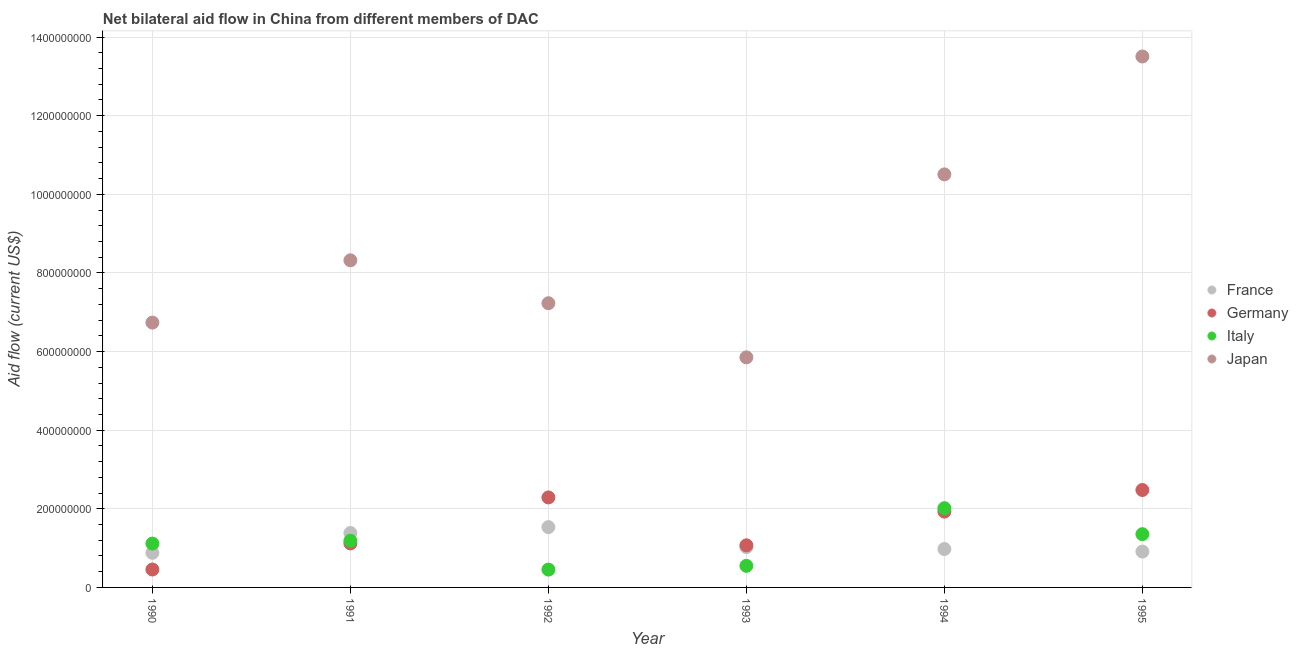What is the amount of aid given by france in 1991?
Provide a succinct answer. 1.38e+08. Across all years, what is the maximum amount of aid given by italy?
Keep it short and to the point. 2.02e+08. Across all years, what is the minimum amount of aid given by germany?
Ensure brevity in your answer.  4.56e+07. What is the total amount of aid given by italy in the graph?
Your response must be concise. 6.68e+08. What is the difference between the amount of aid given by japan in 1992 and that in 1994?
Offer a terse response. -3.28e+08. What is the difference between the amount of aid given by italy in 1994 and the amount of aid given by japan in 1995?
Provide a short and direct response. -1.15e+09. What is the average amount of aid given by japan per year?
Make the answer very short. 8.69e+08. In the year 1995, what is the difference between the amount of aid given by japan and amount of aid given by germany?
Offer a terse response. 1.10e+09. What is the ratio of the amount of aid given by italy in 1992 to that in 1993?
Ensure brevity in your answer.  0.83. Is the amount of aid given by france in 1990 less than that in 1994?
Your response must be concise. Yes. What is the difference between the highest and the second highest amount of aid given by france?
Give a very brief answer. 1.49e+07. What is the difference between the highest and the lowest amount of aid given by france?
Keep it short and to the point. 6.54e+07. In how many years, is the amount of aid given by japan greater than the average amount of aid given by japan taken over all years?
Make the answer very short. 2. Is the sum of the amount of aid given by japan in 1994 and 1995 greater than the maximum amount of aid given by germany across all years?
Give a very brief answer. Yes. Is it the case that in every year, the sum of the amount of aid given by france and amount of aid given by germany is greater than the amount of aid given by italy?
Give a very brief answer. Yes. Is the amount of aid given by france strictly greater than the amount of aid given by italy over the years?
Offer a terse response. No. Is the amount of aid given by italy strictly less than the amount of aid given by france over the years?
Offer a very short reply. No. How many years are there in the graph?
Make the answer very short. 6. Are the values on the major ticks of Y-axis written in scientific E-notation?
Ensure brevity in your answer.  No. Does the graph contain grids?
Offer a very short reply. Yes. How many legend labels are there?
Your response must be concise. 4. How are the legend labels stacked?
Your response must be concise. Vertical. What is the title of the graph?
Offer a terse response. Net bilateral aid flow in China from different members of DAC. What is the label or title of the X-axis?
Your answer should be compact. Year. What is the label or title of the Y-axis?
Offer a very short reply. Aid flow (current US$). What is the Aid flow (current US$) of France in 1990?
Provide a short and direct response. 8.80e+07. What is the Aid flow (current US$) of Germany in 1990?
Ensure brevity in your answer.  4.56e+07. What is the Aid flow (current US$) in Italy in 1990?
Your response must be concise. 1.12e+08. What is the Aid flow (current US$) of Japan in 1990?
Offer a very short reply. 6.74e+08. What is the Aid flow (current US$) of France in 1991?
Your answer should be compact. 1.38e+08. What is the Aid flow (current US$) in Germany in 1991?
Give a very brief answer. 1.12e+08. What is the Aid flow (current US$) of Italy in 1991?
Make the answer very short. 1.19e+08. What is the Aid flow (current US$) in Japan in 1991?
Offer a very short reply. 8.32e+08. What is the Aid flow (current US$) in France in 1992?
Provide a succinct answer. 1.53e+08. What is the Aid flow (current US$) in Germany in 1992?
Ensure brevity in your answer.  2.29e+08. What is the Aid flow (current US$) of Italy in 1992?
Offer a very short reply. 4.53e+07. What is the Aid flow (current US$) in Japan in 1992?
Give a very brief answer. 7.23e+08. What is the Aid flow (current US$) of France in 1993?
Keep it short and to the point. 1.03e+08. What is the Aid flow (current US$) of Germany in 1993?
Offer a terse response. 1.07e+08. What is the Aid flow (current US$) in Italy in 1993?
Your answer should be very brief. 5.49e+07. What is the Aid flow (current US$) of Japan in 1993?
Your answer should be compact. 5.85e+08. What is the Aid flow (current US$) in France in 1994?
Your answer should be compact. 9.77e+07. What is the Aid flow (current US$) of Germany in 1994?
Your answer should be compact. 1.93e+08. What is the Aid flow (current US$) of Italy in 1994?
Your answer should be very brief. 2.02e+08. What is the Aid flow (current US$) in Japan in 1994?
Keep it short and to the point. 1.05e+09. What is the Aid flow (current US$) of France in 1995?
Make the answer very short. 9.12e+07. What is the Aid flow (current US$) of Germany in 1995?
Ensure brevity in your answer.  2.48e+08. What is the Aid flow (current US$) in Italy in 1995?
Your answer should be compact. 1.35e+08. What is the Aid flow (current US$) of Japan in 1995?
Offer a terse response. 1.35e+09. Across all years, what is the maximum Aid flow (current US$) of France?
Offer a terse response. 1.53e+08. Across all years, what is the maximum Aid flow (current US$) in Germany?
Provide a succinct answer. 2.48e+08. Across all years, what is the maximum Aid flow (current US$) of Italy?
Provide a succinct answer. 2.02e+08. Across all years, what is the maximum Aid flow (current US$) of Japan?
Offer a terse response. 1.35e+09. Across all years, what is the minimum Aid flow (current US$) in France?
Make the answer very short. 8.80e+07. Across all years, what is the minimum Aid flow (current US$) in Germany?
Offer a very short reply. 4.56e+07. Across all years, what is the minimum Aid flow (current US$) in Italy?
Your answer should be compact. 4.53e+07. Across all years, what is the minimum Aid flow (current US$) of Japan?
Provide a short and direct response. 5.85e+08. What is the total Aid flow (current US$) of France in the graph?
Your response must be concise. 6.71e+08. What is the total Aid flow (current US$) in Germany in the graph?
Make the answer very short. 9.34e+08. What is the total Aid flow (current US$) of Italy in the graph?
Your response must be concise. 6.68e+08. What is the total Aid flow (current US$) of Japan in the graph?
Provide a succinct answer. 5.22e+09. What is the difference between the Aid flow (current US$) of France in 1990 and that in 1991?
Your response must be concise. -5.04e+07. What is the difference between the Aid flow (current US$) of Germany in 1990 and that in 1991?
Offer a very short reply. -6.63e+07. What is the difference between the Aid flow (current US$) of Italy in 1990 and that in 1991?
Make the answer very short. -7.29e+06. What is the difference between the Aid flow (current US$) in Japan in 1990 and that in 1991?
Your answer should be very brief. -1.58e+08. What is the difference between the Aid flow (current US$) in France in 1990 and that in 1992?
Make the answer very short. -6.54e+07. What is the difference between the Aid flow (current US$) of Germany in 1990 and that in 1992?
Your response must be concise. -1.83e+08. What is the difference between the Aid flow (current US$) of Italy in 1990 and that in 1992?
Provide a succinct answer. 6.62e+07. What is the difference between the Aid flow (current US$) of Japan in 1990 and that in 1992?
Provide a succinct answer. -4.93e+07. What is the difference between the Aid flow (current US$) in France in 1990 and that in 1993?
Your answer should be compact. -1.45e+07. What is the difference between the Aid flow (current US$) in Germany in 1990 and that in 1993?
Offer a terse response. -6.15e+07. What is the difference between the Aid flow (current US$) of Italy in 1990 and that in 1993?
Provide a succinct answer. 5.66e+07. What is the difference between the Aid flow (current US$) of Japan in 1990 and that in 1993?
Offer a very short reply. 8.84e+07. What is the difference between the Aid flow (current US$) of France in 1990 and that in 1994?
Offer a terse response. -9.65e+06. What is the difference between the Aid flow (current US$) of Germany in 1990 and that in 1994?
Make the answer very short. -1.47e+08. What is the difference between the Aid flow (current US$) in Italy in 1990 and that in 1994?
Your response must be concise. -9.00e+07. What is the difference between the Aid flow (current US$) in Japan in 1990 and that in 1994?
Provide a succinct answer. -3.77e+08. What is the difference between the Aid flow (current US$) in France in 1990 and that in 1995?
Offer a very short reply. -3.16e+06. What is the difference between the Aid flow (current US$) of Germany in 1990 and that in 1995?
Keep it short and to the point. -2.02e+08. What is the difference between the Aid flow (current US$) of Italy in 1990 and that in 1995?
Your response must be concise. -2.39e+07. What is the difference between the Aid flow (current US$) of Japan in 1990 and that in 1995?
Offer a terse response. -6.77e+08. What is the difference between the Aid flow (current US$) of France in 1991 and that in 1992?
Provide a short and direct response. -1.49e+07. What is the difference between the Aid flow (current US$) of Germany in 1991 and that in 1992?
Offer a very short reply. -1.17e+08. What is the difference between the Aid flow (current US$) of Italy in 1991 and that in 1992?
Make the answer very short. 7.35e+07. What is the difference between the Aid flow (current US$) in Japan in 1991 and that in 1992?
Keep it short and to the point. 1.09e+08. What is the difference between the Aid flow (current US$) of France in 1991 and that in 1993?
Give a very brief answer. 3.59e+07. What is the difference between the Aid flow (current US$) of Germany in 1991 and that in 1993?
Make the answer very short. 4.80e+06. What is the difference between the Aid flow (current US$) in Italy in 1991 and that in 1993?
Your answer should be very brief. 6.39e+07. What is the difference between the Aid flow (current US$) in Japan in 1991 and that in 1993?
Ensure brevity in your answer.  2.47e+08. What is the difference between the Aid flow (current US$) in France in 1991 and that in 1994?
Provide a succinct answer. 4.08e+07. What is the difference between the Aid flow (current US$) of Germany in 1991 and that in 1994?
Provide a short and direct response. -8.09e+07. What is the difference between the Aid flow (current US$) of Italy in 1991 and that in 1994?
Provide a short and direct response. -8.28e+07. What is the difference between the Aid flow (current US$) of Japan in 1991 and that in 1994?
Offer a very short reply. -2.19e+08. What is the difference between the Aid flow (current US$) of France in 1991 and that in 1995?
Give a very brief answer. 4.73e+07. What is the difference between the Aid flow (current US$) in Germany in 1991 and that in 1995?
Offer a very short reply. -1.36e+08. What is the difference between the Aid flow (current US$) in Italy in 1991 and that in 1995?
Offer a very short reply. -1.66e+07. What is the difference between the Aid flow (current US$) of Japan in 1991 and that in 1995?
Make the answer very short. -5.18e+08. What is the difference between the Aid flow (current US$) of France in 1992 and that in 1993?
Provide a succinct answer. 5.08e+07. What is the difference between the Aid flow (current US$) of Germany in 1992 and that in 1993?
Ensure brevity in your answer.  1.22e+08. What is the difference between the Aid flow (current US$) in Italy in 1992 and that in 1993?
Offer a very short reply. -9.57e+06. What is the difference between the Aid flow (current US$) in Japan in 1992 and that in 1993?
Provide a succinct answer. 1.38e+08. What is the difference between the Aid flow (current US$) of France in 1992 and that in 1994?
Provide a short and direct response. 5.57e+07. What is the difference between the Aid flow (current US$) in Germany in 1992 and that in 1994?
Your answer should be very brief. 3.61e+07. What is the difference between the Aid flow (current US$) of Italy in 1992 and that in 1994?
Keep it short and to the point. -1.56e+08. What is the difference between the Aid flow (current US$) in Japan in 1992 and that in 1994?
Keep it short and to the point. -3.28e+08. What is the difference between the Aid flow (current US$) of France in 1992 and that in 1995?
Make the answer very short. 6.22e+07. What is the difference between the Aid flow (current US$) of Germany in 1992 and that in 1995?
Keep it short and to the point. -1.89e+07. What is the difference between the Aid flow (current US$) in Italy in 1992 and that in 1995?
Give a very brief answer. -9.02e+07. What is the difference between the Aid flow (current US$) in Japan in 1992 and that in 1995?
Ensure brevity in your answer.  -6.28e+08. What is the difference between the Aid flow (current US$) of France in 1993 and that in 1994?
Your response must be concise. 4.89e+06. What is the difference between the Aid flow (current US$) of Germany in 1993 and that in 1994?
Give a very brief answer. -8.57e+07. What is the difference between the Aid flow (current US$) in Italy in 1993 and that in 1994?
Offer a terse response. -1.47e+08. What is the difference between the Aid flow (current US$) in Japan in 1993 and that in 1994?
Your answer should be very brief. -4.65e+08. What is the difference between the Aid flow (current US$) in France in 1993 and that in 1995?
Provide a succinct answer. 1.14e+07. What is the difference between the Aid flow (current US$) of Germany in 1993 and that in 1995?
Offer a terse response. -1.41e+08. What is the difference between the Aid flow (current US$) in Italy in 1993 and that in 1995?
Offer a terse response. -8.06e+07. What is the difference between the Aid flow (current US$) in Japan in 1993 and that in 1995?
Offer a terse response. -7.65e+08. What is the difference between the Aid flow (current US$) in France in 1994 and that in 1995?
Your answer should be compact. 6.49e+06. What is the difference between the Aid flow (current US$) of Germany in 1994 and that in 1995?
Your response must be concise. -5.50e+07. What is the difference between the Aid flow (current US$) in Italy in 1994 and that in 1995?
Your answer should be very brief. 6.61e+07. What is the difference between the Aid flow (current US$) in Japan in 1994 and that in 1995?
Keep it short and to the point. -3.00e+08. What is the difference between the Aid flow (current US$) in France in 1990 and the Aid flow (current US$) in Germany in 1991?
Keep it short and to the point. -2.39e+07. What is the difference between the Aid flow (current US$) in France in 1990 and the Aid flow (current US$) in Italy in 1991?
Provide a succinct answer. -3.08e+07. What is the difference between the Aid flow (current US$) of France in 1990 and the Aid flow (current US$) of Japan in 1991?
Ensure brevity in your answer.  -7.44e+08. What is the difference between the Aid flow (current US$) in Germany in 1990 and the Aid flow (current US$) in Italy in 1991?
Your answer should be very brief. -7.33e+07. What is the difference between the Aid flow (current US$) in Germany in 1990 and the Aid flow (current US$) in Japan in 1991?
Ensure brevity in your answer.  -7.87e+08. What is the difference between the Aid flow (current US$) of Italy in 1990 and the Aid flow (current US$) of Japan in 1991?
Offer a very short reply. -7.21e+08. What is the difference between the Aid flow (current US$) in France in 1990 and the Aid flow (current US$) in Germany in 1992?
Your response must be concise. -1.41e+08. What is the difference between the Aid flow (current US$) of France in 1990 and the Aid flow (current US$) of Italy in 1992?
Ensure brevity in your answer.  4.27e+07. What is the difference between the Aid flow (current US$) of France in 1990 and the Aid flow (current US$) of Japan in 1992?
Your response must be concise. -6.35e+08. What is the difference between the Aid flow (current US$) of Germany in 1990 and the Aid flow (current US$) of Italy in 1992?
Make the answer very short. 2.40e+05. What is the difference between the Aid flow (current US$) in Germany in 1990 and the Aid flow (current US$) in Japan in 1992?
Offer a terse response. -6.77e+08. What is the difference between the Aid flow (current US$) of Italy in 1990 and the Aid flow (current US$) of Japan in 1992?
Your answer should be compact. -6.11e+08. What is the difference between the Aid flow (current US$) of France in 1990 and the Aid flow (current US$) of Germany in 1993?
Ensure brevity in your answer.  -1.91e+07. What is the difference between the Aid flow (current US$) in France in 1990 and the Aid flow (current US$) in Italy in 1993?
Your answer should be compact. 3.31e+07. What is the difference between the Aid flow (current US$) of France in 1990 and the Aid flow (current US$) of Japan in 1993?
Keep it short and to the point. -4.97e+08. What is the difference between the Aid flow (current US$) of Germany in 1990 and the Aid flow (current US$) of Italy in 1993?
Provide a succinct answer. -9.33e+06. What is the difference between the Aid flow (current US$) in Germany in 1990 and the Aid flow (current US$) in Japan in 1993?
Give a very brief answer. -5.40e+08. What is the difference between the Aid flow (current US$) of Italy in 1990 and the Aid flow (current US$) of Japan in 1993?
Your answer should be very brief. -4.74e+08. What is the difference between the Aid flow (current US$) in France in 1990 and the Aid flow (current US$) in Germany in 1994?
Keep it short and to the point. -1.05e+08. What is the difference between the Aid flow (current US$) in France in 1990 and the Aid flow (current US$) in Italy in 1994?
Provide a succinct answer. -1.14e+08. What is the difference between the Aid flow (current US$) in France in 1990 and the Aid flow (current US$) in Japan in 1994?
Give a very brief answer. -9.63e+08. What is the difference between the Aid flow (current US$) of Germany in 1990 and the Aid flow (current US$) of Italy in 1994?
Your answer should be very brief. -1.56e+08. What is the difference between the Aid flow (current US$) of Germany in 1990 and the Aid flow (current US$) of Japan in 1994?
Give a very brief answer. -1.01e+09. What is the difference between the Aid flow (current US$) of Italy in 1990 and the Aid flow (current US$) of Japan in 1994?
Make the answer very short. -9.39e+08. What is the difference between the Aid flow (current US$) in France in 1990 and the Aid flow (current US$) in Germany in 1995?
Keep it short and to the point. -1.60e+08. What is the difference between the Aid flow (current US$) in France in 1990 and the Aid flow (current US$) in Italy in 1995?
Provide a short and direct response. -4.75e+07. What is the difference between the Aid flow (current US$) in France in 1990 and the Aid flow (current US$) in Japan in 1995?
Provide a succinct answer. -1.26e+09. What is the difference between the Aid flow (current US$) in Germany in 1990 and the Aid flow (current US$) in Italy in 1995?
Offer a very short reply. -8.99e+07. What is the difference between the Aid flow (current US$) in Germany in 1990 and the Aid flow (current US$) in Japan in 1995?
Provide a succinct answer. -1.31e+09. What is the difference between the Aid flow (current US$) in Italy in 1990 and the Aid flow (current US$) in Japan in 1995?
Your response must be concise. -1.24e+09. What is the difference between the Aid flow (current US$) of France in 1991 and the Aid flow (current US$) of Germany in 1992?
Offer a terse response. -9.05e+07. What is the difference between the Aid flow (current US$) of France in 1991 and the Aid flow (current US$) of Italy in 1992?
Give a very brief answer. 9.31e+07. What is the difference between the Aid flow (current US$) in France in 1991 and the Aid flow (current US$) in Japan in 1992?
Make the answer very short. -5.85e+08. What is the difference between the Aid flow (current US$) of Germany in 1991 and the Aid flow (current US$) of Italy in 1992?
Your response must be concise. 6.66e+07. What is the difference between the Aid flow (current US$) in Germany in 1991 and the Aid flow (current US$) in Japan in 1992?
Offer a terse response. -6.11e+08. What is the difference between the Aid flow (current US$) in Italy in 1991 and the Aid flow (current US$) in Japan in 1992?
Offer a terse response. -6.04e+08. What is the difference between the Aid flow (current US$) in France in 1991 and the Aid flow (current US$) in Germany in 1993?
Keep it short and to the point. 3.14e+07. What is the difference between the Aid flow (current US$) in France in 1991 and the Aid flow (current US$) in Italy in 1993?
Your answer should be very brief. 8.36e+07. What is the difference between the Aid flow (current US$) in France in 1991 and the Aid flow (current US$) in Japan in 1993?
Your answer should be compact. -4.47e+08. What is the difference between the Aid flow (current US$) of Germany in 1991 and the Aid flow (current US$) of Italy in 1993?
Provide a short and direct response. 5.70e+07. What is the difference between the Aid flow (current US$) of Germany in 1991 and the Aid flow (current US$) of Japan in 1993?
Your answer should be very brief. -4.73e+08. What is the difference between the Aid flow (current US$) of Italy in 1991 and the Aid flow (current US$) of Japan in 1993?
Make the answer very short. -4.66e+08. What is the difference between the Aid flow (current US$) of France in 1991 and the Aid flow (current US$) of Germany in 1994?
Offer a terse response. -5.44e+07. What is the difference between the Aid flow (current US$) of France in 1991 and the Aid flow (current US$) of Italy in 1994?
Make the answer very short. -6.31e+07. What is the difference between the Aid flow (current US$) of France in 1991 and the Aid flow (current US$) of Japan in 1994?
Your answer should be very brief. -9.12e+08. What is the difference between the Aid flow (current US$) of Germany in 1991 and the Aid flow (current US$) of Italy in 1994?
Offer a terse response. -8.97e+07. What is the difference between the Aid flow (current US$) of Germany in 1991 and the Aid flow (current US$) of Japan in 1994?
Offer a very short reply. -9.39e+08. What is the difference between the Aid flow (current US$) of Italy in 1991 and the Aid flow (current US$) of Japan in 1994?
Keep it short and to the point. -9.32e+08. What is the difference between the Aid flow (current US$) in France in 1991 and the Aid flow (current US$) in Germany in 1995?
Offer a very short reply. -1.09e+08. What is the difference between the Aid flow (current US$) of France in 1991 and the Aid flow (current US$) of Italy in 1995?
Your response must be concise. 2.98e+06. What is the difference between the Aid flow (current US$) in France in 1991 and the Aid flow (current US$) in Japan in 1995?
Your response must be concise. -1.21e+09. What is the difference between the Aid flow (current US$) of Germany in 1991 and the Aid flow (current US$) of Italy in 1995?
Make the answer very short. -2.36e+07. What is the difference between the Aid flow (current US$) of Germany in 1991 and the Aid flow (current US$) of Japan in 1995?
Your answer should be very brief. -1.24e+09. What is the difference between the Aid flow (current US$) of Italy in 1991 and the Aid flow (current US$) of Japan in 1995?
Give a very brief answer. -1.23e+09. What is the difference between the Aid flow (current US$) of France in 1992 and the Aid flow (current US$) of Germany in 1993?
Provide a succinct answer. 4.63e+07. What is the difference between the Aid flow (current US$) of France in 1992 and the Aid flow (current US$) of Italy in 1993?
Provide a short and direct response. 9.85e+07. What is the difference between the Aid flow (current US$) in France in 1992 and the Aid flow (current US$) in Japan in 1993?
Your response must be concise. -4.32e+08. What is the difference between the Aid flow (current US$) in Germany in 1992 and the Aid flow (current US$) in Italy in 1993?
Ensure brevity in your answer.  1.74e+08. What is the difference between the Aid flow (current US$) of Germany in 1992 and the Aid flow (current US$) of Japan in 1993?
Keep it short and to the point. -3.56e+08. What is the difference between the Aid flow (current US$) of Italy in 1992 and the Aid flow (current US$) of Japan in 1993?
Offer a terse response. -5.40e+08. What is the difference between the Aid flow (current US$) of France in 1992 and the Aid flow (current US$) of Germany in 1994?
Keep it short and to the point. -3.94e+07. What is the difference between the Aid flow (current US$) of France in 1992 and the Aid flow (current US$) of Italy in 1994?
Offer a terse response. -4.82e+07. What is the difference between the Aid flow (current US$) in France in 1992 and the Aid flow (current US$) in Japan in 1994?
Your answer should be compact. -8.97e+08. What is the difference between the Aid flow (current US$) of Germany in 1992 and the Aid flow (current US$) of Italy in 1994?
Offer a very short reply. 2.74e+07. What is the difference between the Aid flow (current US$) of Germany in 1992 and the Aid flow (current US$) of Japan in 1994?
Ensure brevity in your answer.  -8.22e+08. What is the difference between the Aid flow (current US$) in Italy in 1992 and the Aid flow (current US$) in Japan in 1994?
Make the answer very short. -1.01e+09. What is the difference between the Aid flow (current US$) in France in 1992 and the Aid flow (current US$) in Germany in 1995?
Your answer should be very brief. -9.44e+07. What is the difference between the Aid flow (current US$) of France in 1992 and the Aid flow (current US$) of Italy in 1995?
Give a very brief answer. 1.79e+07. What is the difference between the Aid flow (current US$) of France in 1992 and the Aid flow (current US$) of Japan in 1995?
Your response must be concise. -1.20e+09. What is the difference between the Aid flow (current US$) of Germany in 1992 and the Aid flow (current US$) of Italy in 1995?
Your response must be concise. 9.35e+07. What is the difference between the Aid flow (current US$) of Germany in 1992 and the Aid flow (current US$) of Japan in 1995?
Provide a short and direct response. -1.12e+09. What is the difference between the Aid flow (current US$) of Italy in 1992 and the Aid flow (current US$) of Japan in 1995?
Ensure brevity in your answer.  -1.31e+09. What is the difference between the Aid flow (current US$) of France in 1993 and the Aid flow (current US$) of Germany in 1994?
Keep it short and to the point. -9.03e+07. What is the difference between the Aid flow (current US$) of France in 1993 and the Aid flow (current US$) of Italy in 1994?
Make the answer very short. -9.90e+07. What is the difference between the Aid flow (current US$) of France in 1993 and the Aid flow (current US$) of Japan in 1994?
Keep it short and to the point. -9.48e+08. What is the difference between the Aid flow (current US$) in Germany in 1993 and the Aid flow (current US$) in Italy in 1994?
Your answer should be compact. -9.45e+07. What is the difference between the Aid flow (current US$) of Germany in 1993 and the Aid flow (current US$) of Japan in 1994?
Your answer should be very brief. -9.44e+08. What is the difference between the Aid flow (current US$) of Italy in 1993 and the Aid flow (current US$) of Japan in 1994?
Ensure brevity in your answer.  -9.96e+08. What is the difference between the Aid flow (current US$) in France in 1993 and the Aid flow (current US$) in Germany in 1995?
Provide a succinct answer. -1.45e+08. What is the difference between the Aid flow (current US$) of France in 1993 and the Aid flow (current US$) of Italy in 1995?
Your answer should be very brief. -3.29e+07. What is the difference between the Aid flow (current US$) in France in 1993 and the Aid flow (current US$) in Japan in 1995?
Provide a succinct answer. -1.25e+09. What is the difference between the Aid flow (current US$) in Germany in 1993 and the Aid flow (current US$) in Italy in 1995?
Your answer should be very brief. -2.84e+07. What is the difference between the Aid flow (current US$) in Germany in 1993 and the Aid flow (current US$) in Japan in 1995?
Your response must be concise. -1.24e+09. What is the difference between the Aid flow (current US$) in Italy in 1993 and the Aid flow (current US$) in Japan in 1995?
Your response must be concise. -1.30e+09. What is the difference between the Aid flow (current US$) in France in 1994 and the Aid flow (current US$) in Germany in 1995?
Keep it short and to the point. -1.50e+08. What is the difference between the Aid flow (current US$) in France in 1994 and the Aid flow (current US$) in Italy in 1995?
Offer a terse response. -3.78e+07. What is the difference between the Aid flow (current US$) in France in 1994 and the Aid flow (current US$) in Japan in 1995?
Your answer should be compact. -1.25e+09. What is the difference between the Aid flow (current US$) in Germany in 1994 and the Aid flow (current US$) in Italy in 1995?
Provide a short and direct response. 5.73e+07. What is the difference between the Aid flow (current US$) of Germany in 1994 and the Aid flow (current US$) of Japan in 1995?
Keep it short and to the point. -1.16e+09. What is the difference between the Aid flow (current US$) of Italy in 1994 and the Aid flow (current US$) of Japan in 1995?
Offer a terse response. -1.15e+09. What is the average Aid flow (current US$) of France per year?
Give a very brief answer. 1.12e+08. What is the average Aid flow (current US$) of Germany per year?
Your answer should be compact. 1.56e+08. What is the average Aid flow (current US$) of Italy per year?
Keep it short and to the point. 1.11e+08. What is the average Aid flow (current US$) of Japan per year?
Your answer should be very brief. 8.69e+08. In the year 1990, what is the difference between the Aid flow (current US$) in France and Aid flow (current US$) in Germany?
Offer a very short reply. 4.24e+07. In the year 1990, what is the difference between the Aid flow (current US$) in France and Aid flow (current US$) in Italy?
Your response must be concise. -2.35e+07. In the year 1990, what is the difference between the Aid flow (current US$) in France and Aid flow (current US$) in Japan?
Provide a short and direct response. -5.86e+08. In the year 1990, what is the difference between the Aid flow (current US$) of Germany and Aid flow (current US$) of Italy?
Provide a short and direct response. -6.60e+07. In the year 1990, what is the difference between the Aid flow (current US$) in Germany and Aid flow (current US$) in Japan?
Offer a terse response. -6.28e+08. In the year 1990, what is the difference between the Aid flow (current US$) in Italy and Aid flow (current US$) in Japan?
Your answer should be very brief. -5.62e+08. In the year 1991, what is the difference between the Aid flow (current US$) of France and Aid flow (current US$) of Germany?
Give a very brief answer. 2.66e+07. In the year 1991, what is the difference between the Aid flow (current US$) of France and Aid flow (current US$) of Italy?
Offer a terse response. 1.96e+07. In the year 1991, what is the difference between the Aid flow (current US$) of France and Aid flow (current US$) of Japan?
Provide a short and direct response. -6.94e+08. In the year 1991, what is the difference between the Aid flow (current US$) in Germany and Aid flow (current US$) in Italy?
Make the answer very short. -6.94e+06. In the year 1991, what is the difference between the Aid flow (current US$) of Germany and Aid flow (current US$) of Japan?
Give a very brief answer. -7.20e+08. In the year 1991, what is the difference between the Aid flow (current US$) of Italy and Aid flow (current US$) of Japan?
Give a very brief answer. -7.13e+08. In the year 1992, what is the difference between the Aid flow (current US$) in France and Aid flow (current US$) in Germany?
Offer a terse response. -7.56e+07. In the year 1992, what is the difference between the Aid flow (current US$) of France and Aid flow (current US$) of Italy?
Provide a short and direct response. 1.08e+08. In the year 1992, what is the difference between the Aid flow (current US$) of France and Aid flow (current US$) of Japan?
Provide a succinct answer. -5.70e+08. In the year 1992, what is the difference between the Aid flow (current US$) of Germany and Aid flow (current US$) of Italy?
Your answer should be compact. 1.84e+08. In the year 1992, what is the difference between the Aid flow (current US$) in Germany and Aid flow (current US$) in Japan?
Your response must be concise. -4.94e+08. In the year 1992, what is the difference between the Aid flow (current US$) of Italy and Aid flow (current US$) of Japan?
Keep it short and to the point. -6.78e+08. In the year 1993, what is the difference between the Aid flow (current US$) in France and Aid flow (current US$) in Germany?
Keep it short and to the point. -4.54e+06. In the year 1993, what is the difference between the Aid flow (current US$) in France and Aid flow (current US$) in Italy?
Give a very brief answer. 4.76e+07. In the year 1993, what is the difference between the Aid flow (current US$) in France and Aid flow (current US$) in Japan?
Provide a succinct answer. -4.83e+08. In the year 1993, what is the difference between the Aid flow (current US$) in Germany and Aid flow (current US$) in Italy?
Keep it short and to the point. 5.22e+07. In the year 1993, what is the difference between the Aid flow (current US$) in Germany and Aid flow (current US$) in Japan?
Your response must be concise. -4.78e+08. In the year 1993, what is the difference between the Aid flow (current US$) in Italy and Aid flow (current US$) in Japan?
Your response must be concise. -5.30e+08. In the year 1994, what is the difference between the Aid flow (current US$) in France and Aid flow (current US$) in Germany?
Keep it short and to the point. -9.52e+07. In the year 1994, what is the difference between the Aid flow (current US$) in France and Aid flow (current US$) in Italy?
Give a very brief answer. -1.04e+08. In the year 1994, what is the difference between the Aid flow (current US$) of France and Aid flow (current US$) of Japan?
Give a very brief answer. -9.53e+08. In the year 1994, what is the difference between the Aid flow (current US$) in Germany and Aid flow (current US$) in Italy?
Ensure brevity in your answer.  -8.77e+06. In the year 1994, what is the difference between the Aid flow (current US$) in Germany and Aid flow (current US$) in Japan?
Offer a very short reply. -8.58e+08. In the year 1994, what is the difference between the Aid flow (current US$) in Italy and Aid flow (current US$) in Japan?
Keep it short and to the point. -8.49e+08. In the year 1995, what is the difference between the Aid flow (current US$) in France and Aid flow (current US$) in Germany?
Your answer should be compact. -1.57e+08. In the year 1995, what is the difference between the Aid flow (current US$) of France and Aid flow (current US$) of Italy?
Ensure brevity in your answer.  -4.43e+07. In the year 1995, what is the difference between the Aid flow (current US$) in France and Aid flow (current US$) in Japan?
Provide a short and direct response. -1.26e+09. In the year 1995, what is the difference between the Aid flow (current US$) in Germany and Aid flow (current US$) in Italy?
Your answer should be compact. 1.12e+08. In the year 1995, what is the difference between the Aid flow (current US$) in Germany and Aid flow (current US$) in Japan?
Make the answer very short. -1.10e+09. In the year 1995, what is the difference between the Aid flow (current US$) in Italy and Aid flow (current US$) in Japan?
Your answer should be very brief. -1.22e+09. What is the ratio of the Aid flow (current US$) of France in 1990 to that in 1991?
Provide a succinct answer. 0.64. What is the ratio of the Aid flow (current US$) of Germany in 1990 to that in 1991?
Offer a very short reply. 0.41. What is the ratio of the Aid flow (current US$) in Italy in 1990 to that in 1991?
Make the answer very short. 0.94. What is the ratio of the Aid flow (current US$) of Japan in 1990 to that in 1991?
Keep it short and to the point. 0.81. What is the ratio of the Aid flow (current US$) in France in 1990 to that in 1992?
Provide a succinct answer. 0.57. What is the ratio of the Aid flow (current US$) of Germany in 1990 to that in 1992?
Your answer should be very brief. 0.2. What is the ratio of the Aid flow (current US$) in Italy in 1990 to that in 1992?
Ensure brevity in your answer.  2.46. What is the ratio of the Aid flow (current US$) of Japan in 1990 to that in 1992?
Offer a very short reply. 0.93. What is the ratio of the Aid flow (current US$) of France in 1990 to that in 1993?
Provide a short and direct response. 0.86. What is the ratio of the Aid flow (current US$) of Germany in 1990 to that in 1993?
Give a very brief answer. 0.43. What is the ratio of the Aid flow (current US$) of Italy in 1990 to that in 1993?
Make the answer very short. 2.03. What is the ratio of the Aid flow (current US$) in Japan in 1990 to that in 1993?
Make the answer very short. 1.15. What is the ratio of the Aid flow (current US$) of France in 1990 to that in 1994?
Give a very brief answer. 0.9. What is the ratio of the Aid flow (current US$) in Germany in 1990 to that in 1994?
Offer a terse response. 0.24. What is the ratio of the Aid flow (current US$) in Italy in 1990 to that in 1994?
Keep it short and to the point. 0.55. What is the ratio of the Aid flow (current US$) of Japan in 1990 to that in 1994?
Your response must be concise. 0.64. What is the ratio of the Aid flow (current US$) in France in 1990 to that in 1995?
Offer a very short reply. 0.97. What is the ratio of the Aid flow (current US$) of Germany in 1990 to that in 1995?
Offer a very short reply. 0.18. What is the ratio of the Aid flow (current US$) in Italy in 1990 to that in 1995?
Give a very brief answer. 0.82. What is the ratio of the Aid flow (current US$) in Japan in 1990 to that in 1995?
Provide a short and direct response. 0.5. What is the ratio of the Aid flow (current US$) in France in 1991 to that in 1992?
Your answer should be compact. 0.9. What is the ratio of the Aid flow (current US$) of Germany in 1991 to that in 1992?
Your response must be concise. 0.49. What is the ratio of the Aid flow (current US$) in Italy in 1991 to that in 1992?
Your answer should be very brief. 2.62. What is the ratio of the Aid flow (current US$) in Japan in 1991 to that in 1992?
Provide a succinct answer. 1.15. What is the ratio of the Aid flow (current US$) of France in 1991 to that in 1993?
Provide a succinct answer. 1.35. What is the ratio of the Aid flow (current US$) of Germany in 1991 to that in 1993?
Offer a terse response. 1.04. What is the ratio of the Aid flow (current US$) of Italy in 1991 to that in 1993?
Keep it short and to the point. 2.16. What is the ratio of the Aid flow (current US$) in Japan in 1991 to that in 1993?
Give a very brief answer. 1.42. What is the ratio of the Aid flow (current US$) of France in 1991 to that in 1994?
Your answer should be very brief. 1.42. What is the ratio of the Aid flow (current US$) in Germany in 1991 to that in 1994?
Your answer should be compact. 0.58. What is the ratio of the Aid flow (current US$) of Italy in 1991 to that in 1994?
Offer a very short reply. 0.59. What is the ratio of the Aid flow (current US$) of Japan in 1991 to that in 1994?
Offer a terse response. 0.79. What is the ratio of the Aid flow (current US$) of France in 1991 to that in 1995?
Offer a terse response. 1.52. What is the ratio of the Aid flow (current US$) in Germany in 1991 to that in 1995?
Provide a succinct answer. 0.45. What is the ratio of the Aid flow (current US$) of Italy in 1991 to that in 1995?
Provide a succinct answer. 0.88. What is the ratio of the Aid flow (current US$) in Japan in 1991 to that in 1995?
Provide a short and direct response. 0.62. What is the ratio of the Aid flow (current US$) of France in 1992 to that in 1993?
Give a very brief answer. 1.5. What is the ratio of the Aid flow (current US$) of Germany in 1992 to that in 1993?
Make the answer very short. 2.14. What is the ratio of the Aid flow (current US$) in Italy in 1992 to that in 1993?
Your answer should be very brief. 0.83. What is the ratio of the Aid flow (current US$) of Japan in 1992 to that in 1993?
Provide a short and direct response. 1.24. What is the ratio of the Aid flow (current US$) in France in 1992 to that in 1994?
Keep it short and to the point. 1.57. What is the ratio of the Aid flow (current US$) of Germany in 1992 to that in 1994?
Your response must be concise. 1.19. What is the ratio of the Aid flow (current US$) in Italy in 1992 to that in 1994?
Your response must be concise. 0.22. What is the ratio of the Aid flow (current US$) of Japan in 1992 to that in 1994?
Offer a very short reply. 0.69. What is the ratio of the Aid flow (current US$) in France in 1992 to that in 1995?
Offer a very short reply. 1.68. What is the ratio of the Aid flow (current US$) in Germany in 1992 to that in 1995?
Give a very brief answer. 0.92. What is the ratio of the Aid flow (current US$) in Italy in 1992 to that in 1995?
Your response must be concise. 0.33. What is the ratio of the Aid flow (current US$) of Japan in 1992 to that in 1995?
Keep it short and to the point. 0.54. What is the ratio of the Aid flow (current US$) in France in 1993 to that in 1994?
Your response must be concise. 1.05. What is the ratio of the Aid flow (current US$) of Germany in 1993 to that in 1994?
Provide a short and direct response. 0.56. What is the ratio of the Aid flow (current US$) of Italy in 1993 to that in 1994?
Offer a very short reply. 0.27. What is the ratio of the Aid flow (current US$) of Japan in 1993 to that in 1994?
Provide a short and direct response. 0.56. What is the ratio of the Aid flow (current US$) of France in 1993 to that in 1995?
Provide a short and direct response. 1.12. What is the ratio of the Aid flow (current US$) of Germany in 1993 to that in 1995?
Your response must be concise. 0.43. What is the ratio of the Aid flow (current US$) in Italy in 1993 to that in 1995?
Give a very brief answer. 0.41. What is the ratio of the Aid flow (current US$) in Japan in 1993 to that in 1995?
Your answer should be compact. 0.43. What is the ratio of the Aid flow (current US$) in France in 1994 to that in 1995?
Give a very brief answer. 1.07. What is the ratio of the Aid flow (current US$) in Germany in 1994 to that in 1995?
Give a very brief answer. 0.78. What is the ratio of the Aid flow (current US$) in Italy in 1994 to that in 1995?
Your answer should be compact. 1.49. What is the ratio of the Aid flow (current US$) in Japan in 1994 to that in 1995?
Give a very brief answer. 0.78. What is the difference between the highest and the second highest Aid flow (current US$) of France?
Provide a succinct answer. 1.49e+07. What is the difference between the highest and the second highest Aid flow (current US$) of Germany?
Give a very brief answer. 1.89e+07. What is the difference between the highest and the second highest Aid flow (current US$) in Italy?
Your response must be concise. 6.61e+07. What is the difference between the highest and the second highest Aid flow (current US$) of Japan?
Offer a very short reply. 3.00e+08. What is the difference between the highest and the lowest Aid flow (current US$) in France?
Offer a very short reply. 6.54e+07. What is the difference between the highest and the lowest Aid flow (current US$) in Germany?
Your answer should be compact. 2.02e+08. What is the difference between the highest and the lowest Aid flow (current US$) in Italy?
Your answer should be compact. 1.56e+08. What is the difference between the highest and the lowest Aid flow (current US$) of Japan?
Your answer should be very brief. 7.65e+08. 